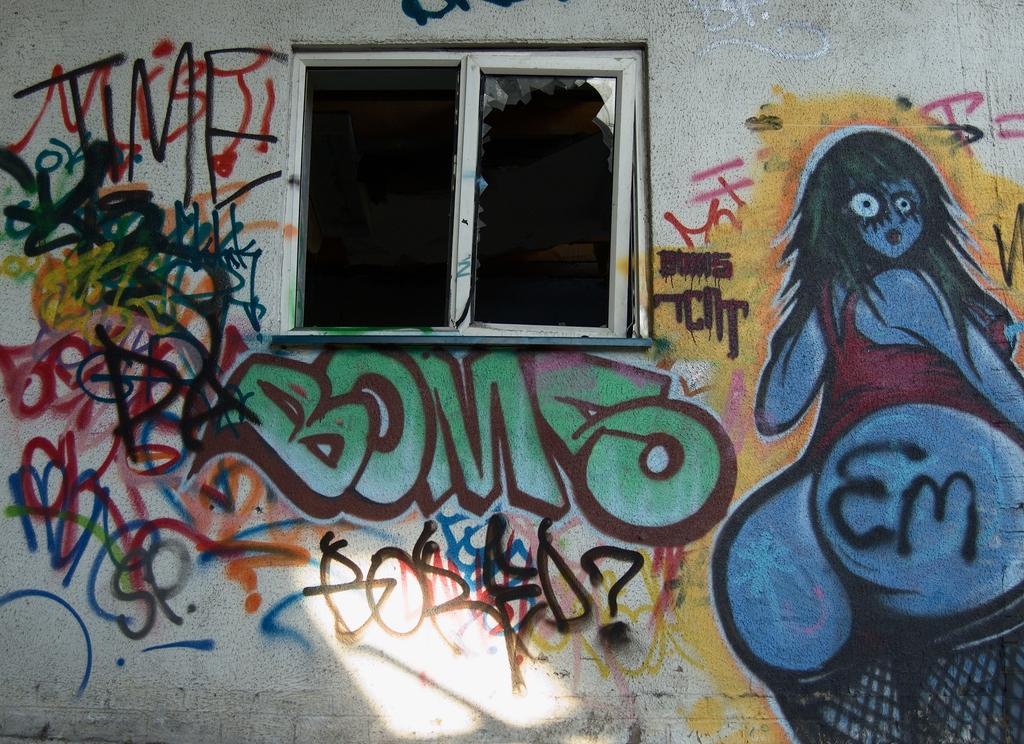Can you describe this image briefly? In this picture we can observe a wall and there is a window. We can observe graffiti art on the wall. There are different colors on the white color wall. 